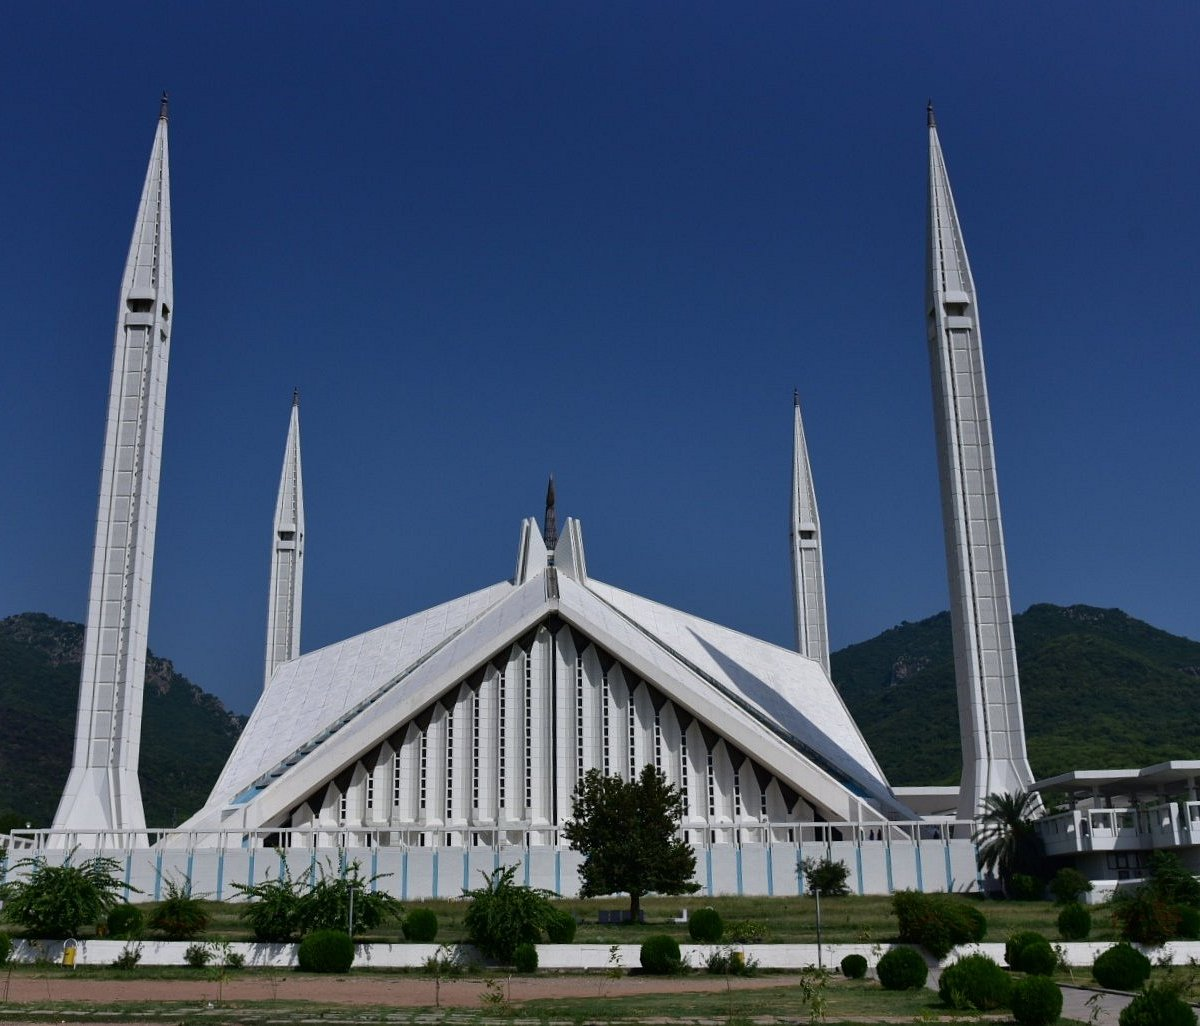What is the significance of this mosque to the local community? Faisal Mosque holds immense significance for the local community not just as a place of worship but also as a cultural and social hub. Funded by King Faisal of Saudi Arabia, it represents the friendship between Pakistan and Saudi Arabia. The mosque can accommodate about 100,000 worshipers, making it a central venue for major Islamic events and holidays. It also attracts numerous visitors and tourists, adding to its role in promoting Islamic culture and strengthening community ties in Islamabad. 